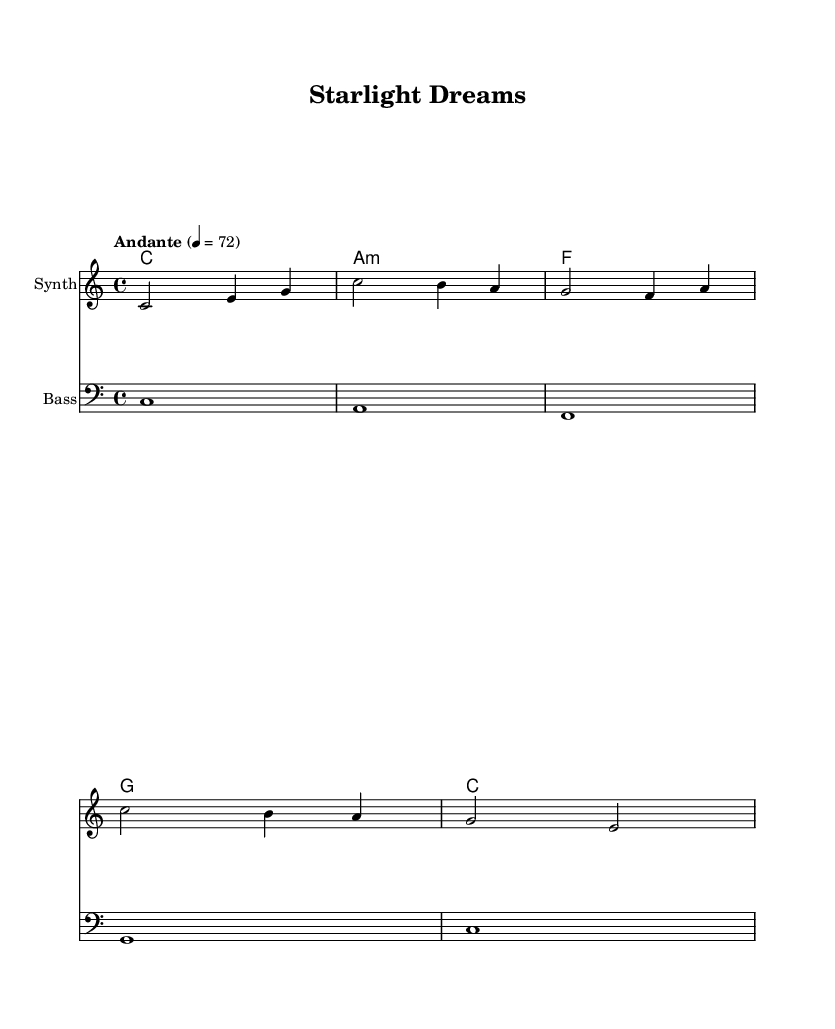What is the key signature of this music? The key signature shown is C major, which has no sharps or flats.
Answer: C major What is the time signature of this piece? The time signature is indicated at the beginning of the score as 4/4, meaning four beats per measure.
Answer: 4/4 What is the tempo marking for this music? The tempo marking is "Andante," which typically suggests a moderate walking pace, indicated by the tempo marking of 72 beats per minute.
Answer: Andante How many measures are in the melody part? By counting the measures in the melody section, we find there are 5 measures in total.
Answer: 5 What is the name of the piece? The title of the piece is prominently displayed at the top of the score and is "Starlight Dreams."
Answer: Starlight Dreams What type of electronic instrument is used for the melody? The instrument indicated for the melody part is a "Synth," explicitly noted in the score.
Answer: Synth What is the chord progression for the first section? Analyzing the chord mode, the progression for the first section is C, A minor, F, and G.
Answer: C, A minor, F, G 